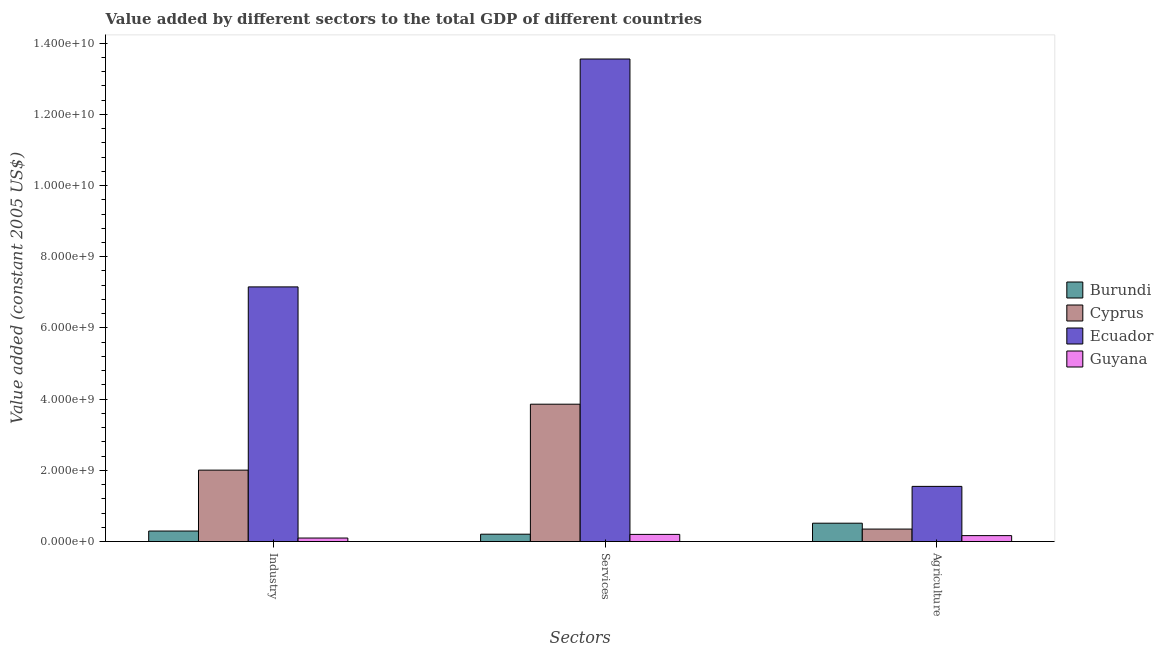How many different coloured bars are there?
Provide a succinct answer. 4. How many groups of bars are there?
Give a very brief answer. 3. Are the number of bars per tick equal to the number of legend labels?
Provide a short and direct response. Yes. What is the label of the 3rd group of bars from the left?
Give a very brief answer. Agriculture. What is the value added by agricultural sector in Cyprus?
Ensure brevity in your answer.  3.51e+08. Across all countries, what is the maximum value added by services?
Give a very brief answer. 1.36e+1. Across all countries, what is the minimum value added by industrial sector?
Offer a terse response. 9.87e+07. In which country was the value added by industrial sector maximum?
Your response must be concise. Ecuador. In which country was the value added by services minimum?
Ensure brevity in your answer.  Guyana. What is the total value added by agricultural sector in the graph?
Keep it short and to the point. 2.58e+09. What is the difference between the value added by industrial sector in Ecuador and that in Burundi?
Offer a very short reply. 6.86e+09. What is the difference between the value added by agricultural sector in Burundi and the value added by industrial sector in Cyprus?
Provide a short and direct response. -1.49e+09. What is the average value added by industrial sector per country?
Give a very brief answer. 2.39e+09. What is the difference between the value added by services and value added by industrial sector in Cyprus?
Provide a succinct answer. 1.85e+09. In how many countries, is the value added by services greater than 2400000000 US$?
Your answer should be very brief. 2. What is the ratio of the value added by agricultural sector in Cyprus to that in Burundi?
Your answer should be very brief. 0.68. Is the value added by industrial sector in Ecuador less than that in Burundi?
Your answer should be compact. No. What is the difference between the highest and the second highest value added by industrial sector?
Provide a short and direct response. 5.15e+09. What is the difference between the highest and the lowest value added by industrial sector?
Offer a very short reply. 7.05e+09. Is the sum of the value added by industrial sector in Guyana and Burundi greater than the maximum value added by services across all countries?
Offer a terse response. No. What does the 2nd bar from the left in Services represents?
Provide a succinct answer. Cyprus. What does the 3rd bar from the right in Services represents?
Provide a succinct answer. Cyprus. How many bars are there?
Give a very brief answer. 12. How many legend labels are there?
Offer a terse response. 4. What is the title of the graph?
Offer a terse response. Value added by different sectors to the total GDP of different countries. Does "Kosovo" appear as one of the legend labels in the graph?
Offer a terse response. No. What is the label or title of the X-axis?
Give a very brief answer. Sectors. What is the label or title of the Y-axis?
Provide a short and direct response. Value added (constant 2005 US$). What is the Value added (constant 2005 US$) of Burundi in Industry?
Your response must be concise. 2.96e+08. What is the Value added (constant 2005 US$) of Cyprus in Industry?
Offer a terse response. 2.01e+09. What is the Value added (constant 2005 US$) in Ecuador in Industry?
Give a very brief answer. 7.15e+09. What is the Value added (constant 2005 US$) of Guyana in Industry?
Provide a succinct answer. 9.87e+07. What is the Value added (constant 2005 US$) in Burundi in Services?
Provide a short and direct response. 2.07e+08. What is the Value added (constant 2005 US$) of Cyprus in Services?
Your answer should be very brief. 3.86e+09. What is the Value added (constant 2005 US$) in Ecuador in Services?
Your answer should be very brief. 1.36e+1. What is the Value added (constant 2005 US$) in Guyana in Services?
Ensure brevity in your answer.  2.01e+08. What is the Value added (constant 2005 US$) of Burundi in Agriculture?
Make the answer very short. 5.16e+08. What is the Value added (constant 2005 US$) of Cyprus in Agriculture?
Keep it short and to the point. 3.51e+08. What is the Value added (constant 2005 US$) in Ecuador in Agriculture?
Offer a terse response. 1.55e+09. What is the Value added (constant 2005 US$) in Guyana in Agriculture?
Give a very brief answer. 1.67e+08. Across all Sectors, what is the maximum Value added (constant 2005 US$) of Burundi?
Give a very brief answer. 5.16e+08. Across all Sectors, what is the maximum Value added (constant 2005 US$) of Cyprus?
Your response must be concise. 3.86e+09. Across all Sectors, what is the maximum Value added (constant 2005 US$) in Ecuador?
Your answer should be compact. 1.36e+1. Across all Sectors, what is the maximum Value added (constant 2005 US$) in Guyana?
Offer a very short reply. 2.01e+08. Across all Sectors, what is the minimum Value added (constant 2005 US$) of Burundi?
Your answer should be very brief. 2.07e+08. Across all Sectors, what is the minimum Value added (constant 2005 US$) of Cyprus?
Provide a succinct answer. 3.51e+08. Across all Sectors, what is the minimum Value added (constant 2005 US$) of Ecuador?
Make the answer very short. 1.55e+09. Across all Sectors, what is the minimum Value added (constant 2005 US$) in Guyana?
Keep it short and to the point. 9.87e+07. What is the total Value added (constant 2005 US$) of Burundi in the graph?
Offer a very short reply. 1.02e+09. What is the total Value added (constant 2005 US$) of Cyprus in the graph?
Your answer should be very brief. 6.22e+09. What is the total Value added (constant 2005 US$) of Ecuador in the graph?
Your response must be concise. 2.23e+1. What is the total Value added (constant 2005 US$) of Guyana in the graph?
Your answer should be compact. 4.67e+08. What is the difference between the Value added (constant 2005 US$) in Burundi in Industry and that in Services?
Your answer should be compact. 8.88e+07. What is the difference between the Value added (constant 2005 US$) in Cyprus in Industry and that in Services?
Offer a very short reply. -1.85e+09. What is the difference between the Value added (constant 2005 US$) in Ecuador in Industry and that in Services?
Offer a terse response. -6.40e+09. What is the difference between the Value added (constant 2005 US$) in Guyana in Industry and that in Services?
Your answer should be compact. -1.02e+08. What is the difference between the Value added (constant 2005 US$) of Burundi in Industry and that in Agriculture?
Make the answer very short. -2.20e+08. What is the difference between the Value added (constant 2005 US$) of Cyprus in Industry and that in Agriculture?
Your answer should be very brief. 1.66e+09. What is the difference between the Value added (constant 2005 US$) in Ecuador in Industry and that in Agriculture?
Ensure brevity in your answer.  5.60e+09. What is the difference between the Value added (constant 2005 US$) of Guyana in Industry and that in Agriculture?
Provide a succinct answer. -6.81e+07. What is the difference between the Value added (constant 2005 US$) of Burundi in Services and that in Agriculture?
Offer a terse response. -3.09e+08. What is the difference between the Value added (constant 2005 US$) of Cyprus in Services and that in Agriculture?
Ensure brevity in your answer.  3.51e+09. What is the difference between the Value added (constant 2005 US$) of Ecuador in Services and that in Agriculture?
Your answer should be compact. 1.20e+1. What is the difference between the Value added (constant 2005 US$) in Guyana in Services and that in Agriculture?
Make the answer very short. 3.43e+07. What is the difference between the Value added (constant 2005 US$) of Burundi in Industry and the Value added (constant 2005 US$) of Cyprus in Services?
Ensure brevity in your answer.  -3.56e+09. What is the difference between the Value added (constant 2005 US$) of Burundi in Industry and the Value added (constant 2005 US$) of Ecuador in Services?
Offer a terse response. -1.33e+1. What is the difference between the Value added (constant 2005 US$) of Burundi in Industry and the Value added (constant 2005 US$) of Guyana in Services?
Provide a short and direct response. 9.45e+07. What is the difference between the Value added (constant 2005 US$) in Cyprus in Industry and the Value added (constant 2005 US$) in Ecuador in Services?
Ensure brevity in your answer.  -1.15e+1. What is the difference between the Value added (constant 2005 US$) of Cyprus in Industry and the Value added (constant 2005 US$) of Guyana in Services?
Give a very brief answer. 1.81e+09. What is the difference between the Value added (constant 2005 US$) of Ecuador in Industry and the Value added (constant 2005 US$) of Guyana in Services?
Keep it short and to the point. 6.95e+09. What is the difference between the Value added (constant 2005 US$) in Burundi in Industry and the Value added (constant 2005 US$) in Cyprus in Agriculture?
Your answer should be compact. -5.52e+07. What is the difference between the Value added (constant 2005 US$) in Burundi in Industry and the Value added (constant 2005 US$) in Ecuador in Agriculture?
Give a very brief answer. -1.25e+09. What is the difference between the Value added (constant 2005 US$) of Burundi in Industry and the Value added (constant 2005 US$) of Guyana in Agriculture?
Your answer should be compact. 1.29e+08. What is the difference between the Value added (constant 2005 US$) of Cyprus in Industry and the Value added (constant 2005 US$) of Ecuador in Agriculture?
Ensure brevity in your answer.  4.56e+08. What is the difference between the Value added (constant 2005 US$) in Cyprus in Industry and the Value added (constant 2005 US$) in Guyana in Agriculture?
Make the answer very short. 1.84e+09. What is the difference between the Value added (constant 2005 US$) in Ecuador in Industry and the Value added (constant 2005 US$) in Guyana in Agriculture?
Make the answer very short. 6.99e+09. What is the difference between the Value added (constant 2005 US$) in Burundi in Services and the Value added (constant 2005 US$) in Cyprus in Agriculture?
Your answer should be compact. -1.44e+08. What is the difference between the Value added (constant 2005 US$) in Burundi in Services and the Value added (constant 2005 US$) in Ecuador in Agriculture?
Your response must be concise. -1.34e+09. What is the difference between the Value added (constant 2005 US$) in Burundi in Services and the Value added (constant 2005 US$) in Guyana in Agriculture?
Your answer should be compact. 4.00e+07. What is the difference between the Value added (constant 2005 US$) of Cyprus in Services and the Value added (constant 2005 US$) of Ecuador in Agriculture?
Keep it short and to the point. 2.31e+09. What is the difference between the Value added (constant 2005 US$) of Cyprus in Services and the Value added (constant 2005 US$) of Guyana in Agriculture?
Keep it short and to the point. 3.69e+09. What is the difference between the Value added (constant 2005 US$) in Ecuador in Services and the Value added (constant 2005 US$) in Guyana in Agriculture?
Your answer should be compact. 1.34e+1. What is the average Value added (constant 2005 US$) of Burundi per Sectors?
Provide a short and direct response. 3.39e+08. What is the average Value added (constant 2005 US$) in Cyprus per Sectors?
Make the answer very short. 2.07e+09. What is the average Value added (constant 2005 US$) in Ecuador per Sectors?
Ensure brevity in your answer.  7.42e+09. What is the average Value added (constant 2005 US$) in Guyana per Sectors?
Offer a terse response. 1.56e+08. What is the difference between the Value added (constant 2005 US$) of Burundi and Value added (constant 2005 US$) of Cyprus in Industry?
Offer a very short reply. -1.71e+09. What is the difference between the Value added (constant 2005 US$) in Burundi and Value added (constant 2005 US$) in Ecuador in Industry?
Make the answer very short. -6.86e+09. What is the difference between the Value added (constant 2005 US$) in Burundi and Value added (constant 2005 US$) in Guyana in Industry?
Keep it short and to the point. 1.97e+08. What is the difference between the Value added (constant 2005 US$) in Cyprus and Value added (constant 2005 US$) in Ecuador in Industry?
Provide a succinct answer. -5.15e+09. What is the difference between the Value added (constant 2005 US$) in Cyprus and Value added (constant 2005 US$) in Guyana in Industry?
Your response must be concise. 1.91e+09. What is the difference between the Value added (constant 2005 US$) in Ecuador and Value added (constant 2005 US$) in Guyana in Industry?
Your response must be concise. 7.05e+09. What is the difference between the Value added (constant 2005 US$) in Burundi and Value added (constant 2005 US$) in Cyprus in Services?
Offer a terse response. -3.65e+09. What is the difference between the Value added (constant 2005 US$) in Burundi and Value added (constant 2005 US$) in Ecuador in Services?
Keep it short and to the point. -1.33e+1. What is the difference between the Value added (constant 2005 US$) of Burundi and Value added (constant 2005 US$) of Guyana in Services?
Make the answer very short. 5.75e+06. What is the difference between the Value added (constant 2005 US$) in Cyprus and Value added (constant 2005 US$) in Ecuador in Services?
Your response must be concise. -9.70e+09. What is the difference between the Value added (constant 2005 US$) of Cyprus and Value added (constant 2005 US$) of Guyana in Services?
Offer a terse response. 3.66e+09. What is the difference between the Value added (constant 2005 US$) in Ecuador and Value added (constant 2005 US$) in Guyana in Services?
Ensure brevity in your answer.  1.34e+1. What is the difference between the Value added (constant 2005 US$) of Burundi and Value added (constant 2005 US$) of Cyprus in Agriculture?
Provide a succinct answer. 1.65e+08. What is the difference between the Value added (constant 2005 US$) of Burundi and Value added (constant 2005 US$) of Ecuador in Agriculture?
Make the answer very short. -1.03e+09. What is the difference between the Value added (constant 2005 US$) of Burundi and Value added (constant 2005 US$) of Guyana in Agriculture?
Give a very brief answer. 3.49e+08. What is the difference between the Value added (constant 2005 US$) of Cyprus and Value added (constant 2005 US$) of Ecuador in Agriculture?
Your response must be concise. -1.20e+09. What is the difference between the Value added (constant 2005 US$) of Cyprus and Value added (constant 2005 US$) of Guyana in Agriculture?
Make the answer very short. 1.84e+08. What is the difference between the Value added (constant 2005 US$) in Ecuador and Value added (constant 2005 US$) in Guyana in Agriculture?
Give a very brief answer. 1.38e+09. What is the ratio of the Value added (constant 2005 US$) of Burundi in Industry to that in Services?
Provide a succinct answer. 1.43. What is the ratio of the Value added (constant 2005 US$) of Cyprus in Industry to that in Services?
Ensure brevity in your answer.  0.52. What is the ratio of the Value added (constant 2005 US$) in Ecuador in Industry to that in Services?
Provide a succinct answer. 0.53. What is the ratio of the Value added (constant 2005 US$) of Guyana in Industry to that in Services?
Offer a very short reply. 0.49. What is the ratio of the Value added (constant 2005 US$) of Burundi in Industry to that in Agriculture?
Make the answer very short. 0.57. What is the ratio of the Value added (constant 2005 US$) in Cyprus in Industry to that in Agriculture?
Offer a very short reply. 5.72. What is the ratio of the Value added (constant 2005 US$) in Ecuador in Industry to that in Agriculture?
Make the answer very short. 4.61. What is the ratio of the Value added (constant 2005 US$) of Guyana in Industry to that in Agriculture?
Make the answer very short. 0.59. What is the ratio of the Value added (constant 2005 US$) of Burundi in Services to that in Agriculture?
Ensure brevity in your answer.  0.4. What is the ratio of the Value added (constant 2005 US$) of Cyprus in Services to that in Agriculture?
Your response must be concise. 11. What is the ratio of the Value added (constant 2005 US$) in Ecuador in Services to that in Agriculture?
Provide a short and direct response. 8.74. What is the ratio of the Value added (constant 2005 US$) of Guyana in Services to that in Agriculture?
Keep it short and to the point. 1.21. What is the difference between the highest and the second highest Value added (constant 2005 US$) of Burundi?
Offer a terse response. 2.20e+08. What is the difference between the highest and the second highest Value added (constant 2005 US$) in Cyprus?
Make the answer very short. 1.85e+09. What is the difference between the highest and the second highest Value added (constant 2005 US$) of Ecuador?
Ensure brevity in your answer.  6.40e+09. What is the difference between the highest and the second highest Value added (constant 2005 US$) in Guyana?
Give a very brief answer. 3.43e+07. What is the difference between the highest and the lowest Value added (constant 2005 US$) of Burundi?
Make the answer very short. 3.09e+08. What is the difference between the highest and the lowest Value added (constant 2005 US$) of Cyprus?
Make the answer very short. 3.51e+09. What is the difference between the highest and the lowest Value added (constant 2005 US$) of Ecuador?
Your answer should be compact. 1.20e+1. What is the difference between the highest and the lowest Value added (constant 2005 US$) of Guyana?
Make the answer very short. 1.02e+08. 